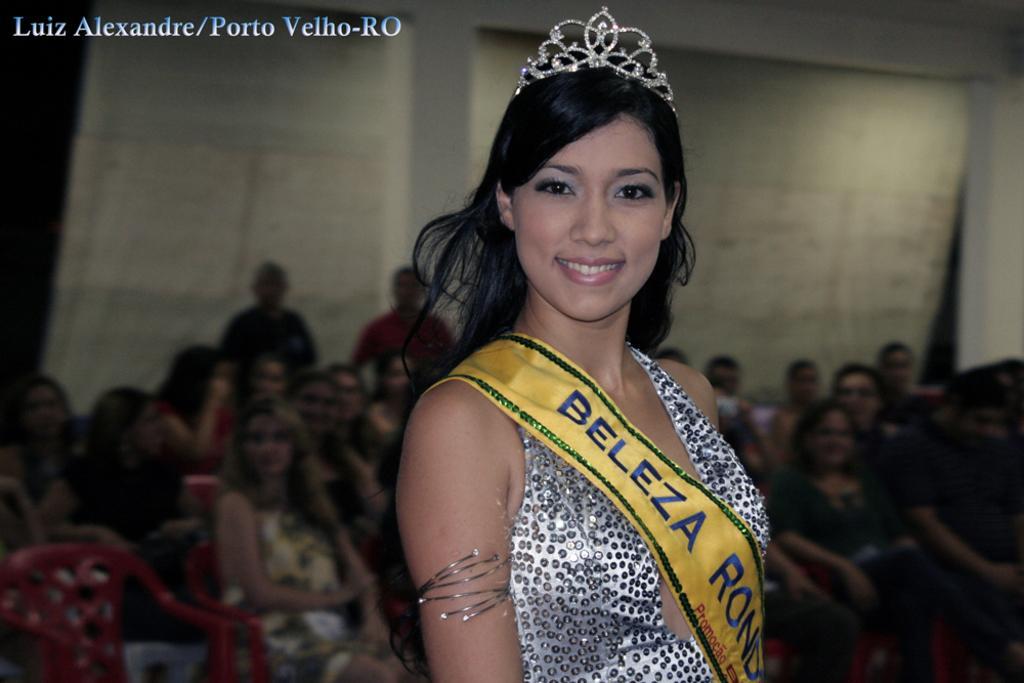Describe this image in one or two sentences. In this image we can see a woman wearing a dress with long hair and a crown on her head. In the background, we can see a group of people sitting on chairs and curtains. 